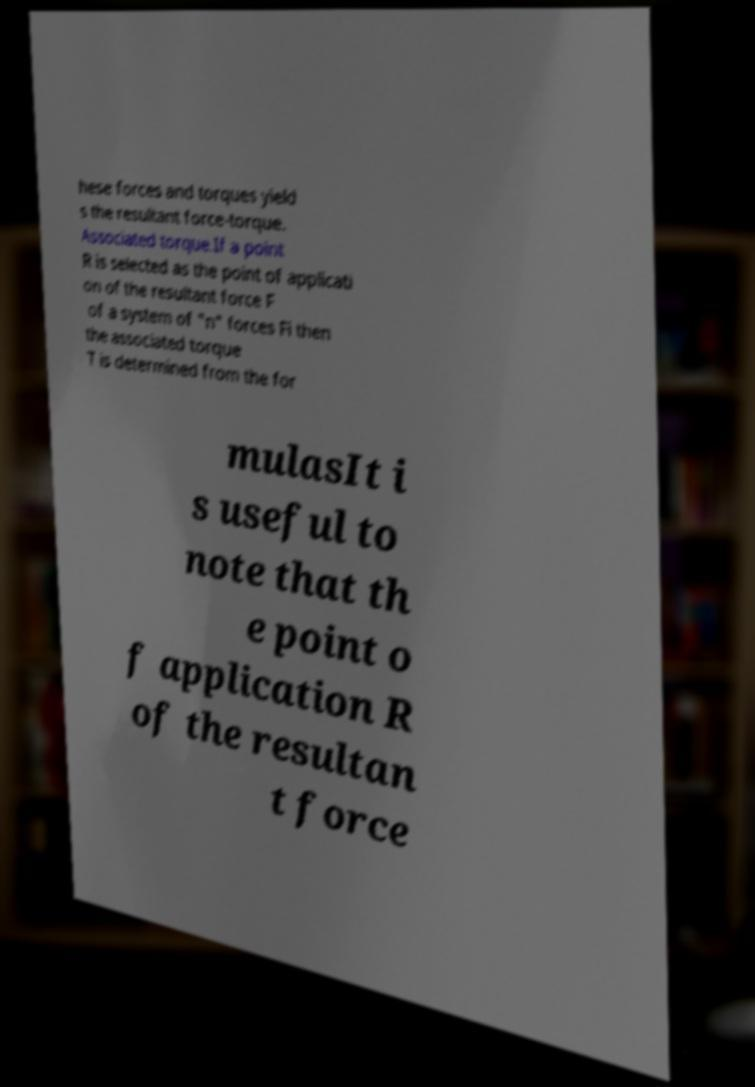There's text embedded in this image that I need extracted. Can you transcribe it verbatim? hese forces and torques yield s the resultant force-torque. Associated torque.If a point R is selected as the point of applicati on of the resultant force F of a system of "n" forces Fi then the associated torque T is determined from the for mulasIt i s useful to note that th e point o f application R of the resultan t force 